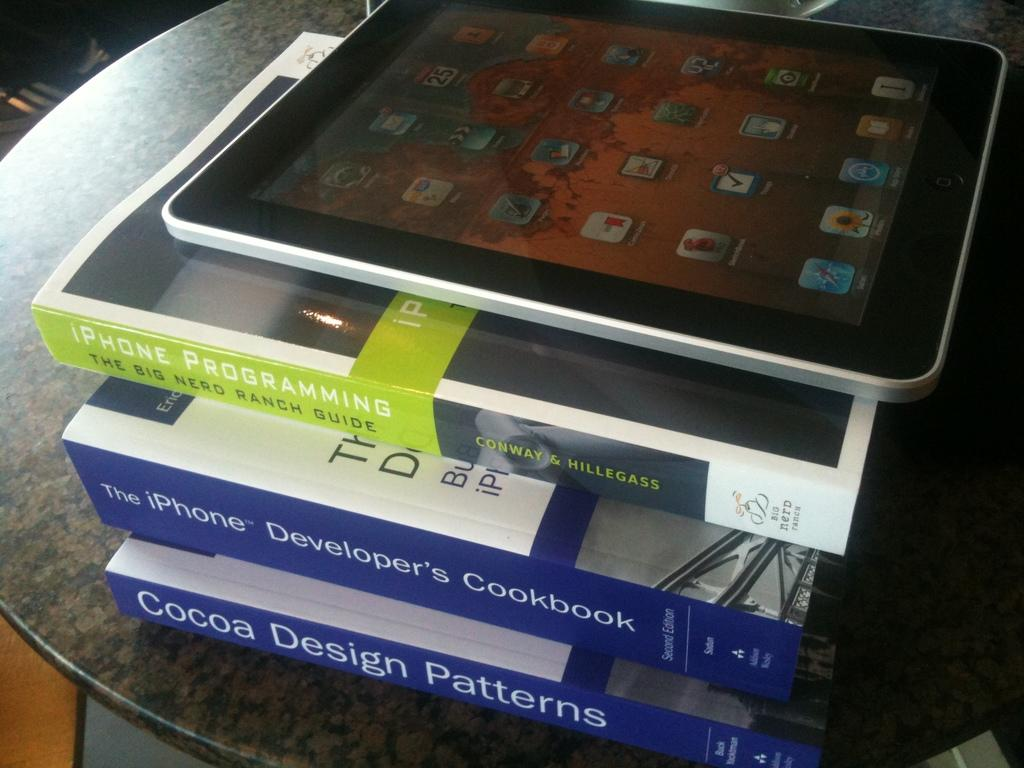<image>
Present a compact description of the photo's key features. An ipad sits on top of a book called Iphone Programming 